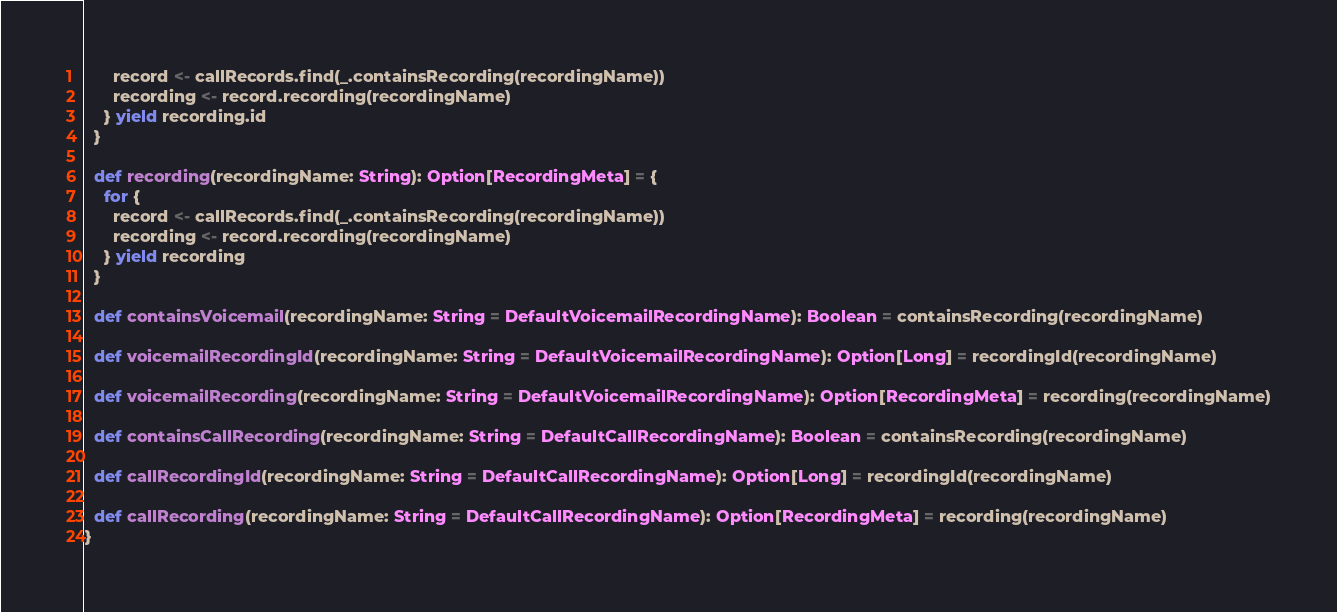Convert code to text. <code><loc_0><loc_0><loc_500><loc_500><_Scala_>      record <- callRecords.find(_.containsRecording(recordingName))
      recording <- record.recording(recordingName)
    } yield recording.id
  }

  def recording(recordingName: String): Option[RecordingMeta] = {
    for {
      record <- callRecords.find(_.containsRecording(recordingName))
      recording <- record.recording(recordingName)
    } yield recording
  }

  def containsVoicemail(recordingName: String = DefaultVoicemailRecordingName): Boolean = containsRecording(recordingName)

  def voicemailRecordingId(recordingName: String = DefaultVoicemailRecordingName): Option[Long] = recordingId(recordingName)

  def voicemailRecording(recordingName: String = DefaultVoicemailRecordingName): Option[RecordingMeta] = recording(recordingName)

  def containsCallRecording(recordingName: String = DefaultCallRecordingName): Boolean = containsRecording(recordingName)

  def callRecordingId(recordingName: String = DefaultCallRecordingName): Option[Long] = recordingId(recordingName)

  def callRecording(recordingName: String = DefaultCallRecordingName): Option[RecordingMeta] = recording(recordingName)
}

</code> 